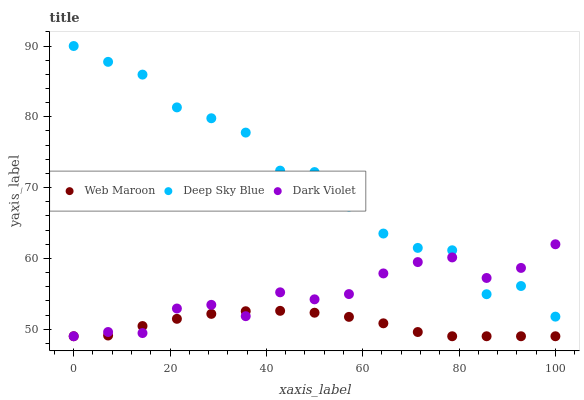Does Web Maroon have the minimum area under the curve?
Answer yes or no. Yes. Does Deep Sky Blue have the maximum area under the curve?
Answer yes or no. Yes. Does Dark Violet have the minimum area under the curve?
Answer yes or no. No. Does Dark Violet have the maximum area under the curve?
Answer yes or no. No. Is Web Maroon the smoothest?
Answer yes or no. Yes. Is Deep Sky Blue the roughest?
Answer yes or no. Yes. Is Dark Violet the smoothest?
Answer yes or no. No. Is Dark Violet the roughest?
Answer yes or no. No. Does Web Maroon have the lowest value?
Answer yes or no. Yes. Does Deep Sky Blue have the lowest value?
Answer yes or no. No. Does Deep Sky Blue have the highest value?
Answer yes or no. Yes. Does Dark Violet have the highest value?
Answer yes or no. No. Is Web Maroon less than Deep Sky Blue?
Answer yes or no. Yes. Is Deep Sky Blue greater than Web Maroon?
Answer yes or no. Yes. Does Web Maroon intersect Dark Violet?
Answer yes or no. Yes. Is Web Maroon less than Dark Violet?
Answer yes or no. No. Is Web Maroon greater than Dark Violet?
Answer yes or no. No. Does Web Maroon intersect Deep Sky Blue?
Answer yes or no. No. 